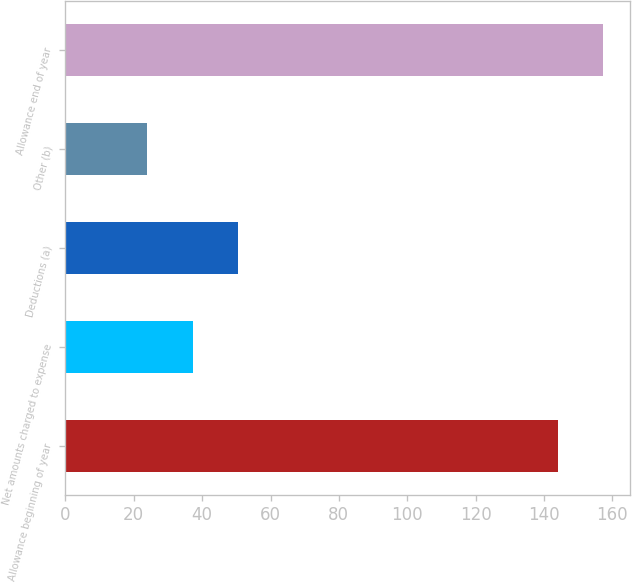Convert chart. <chart><loc_0><loc_0><loc_500><loc_500><bar_chart><fcel>Allowance beginning of year<fcel>Net amounts charged to expense<fcel>Deductions (a)<fcel>Other (b)<fcel>Allowance end of year<nl><fcel>144<fcel>37.3<fcel>50.6<fcel>24<fcel>157.3<nl></chart> 